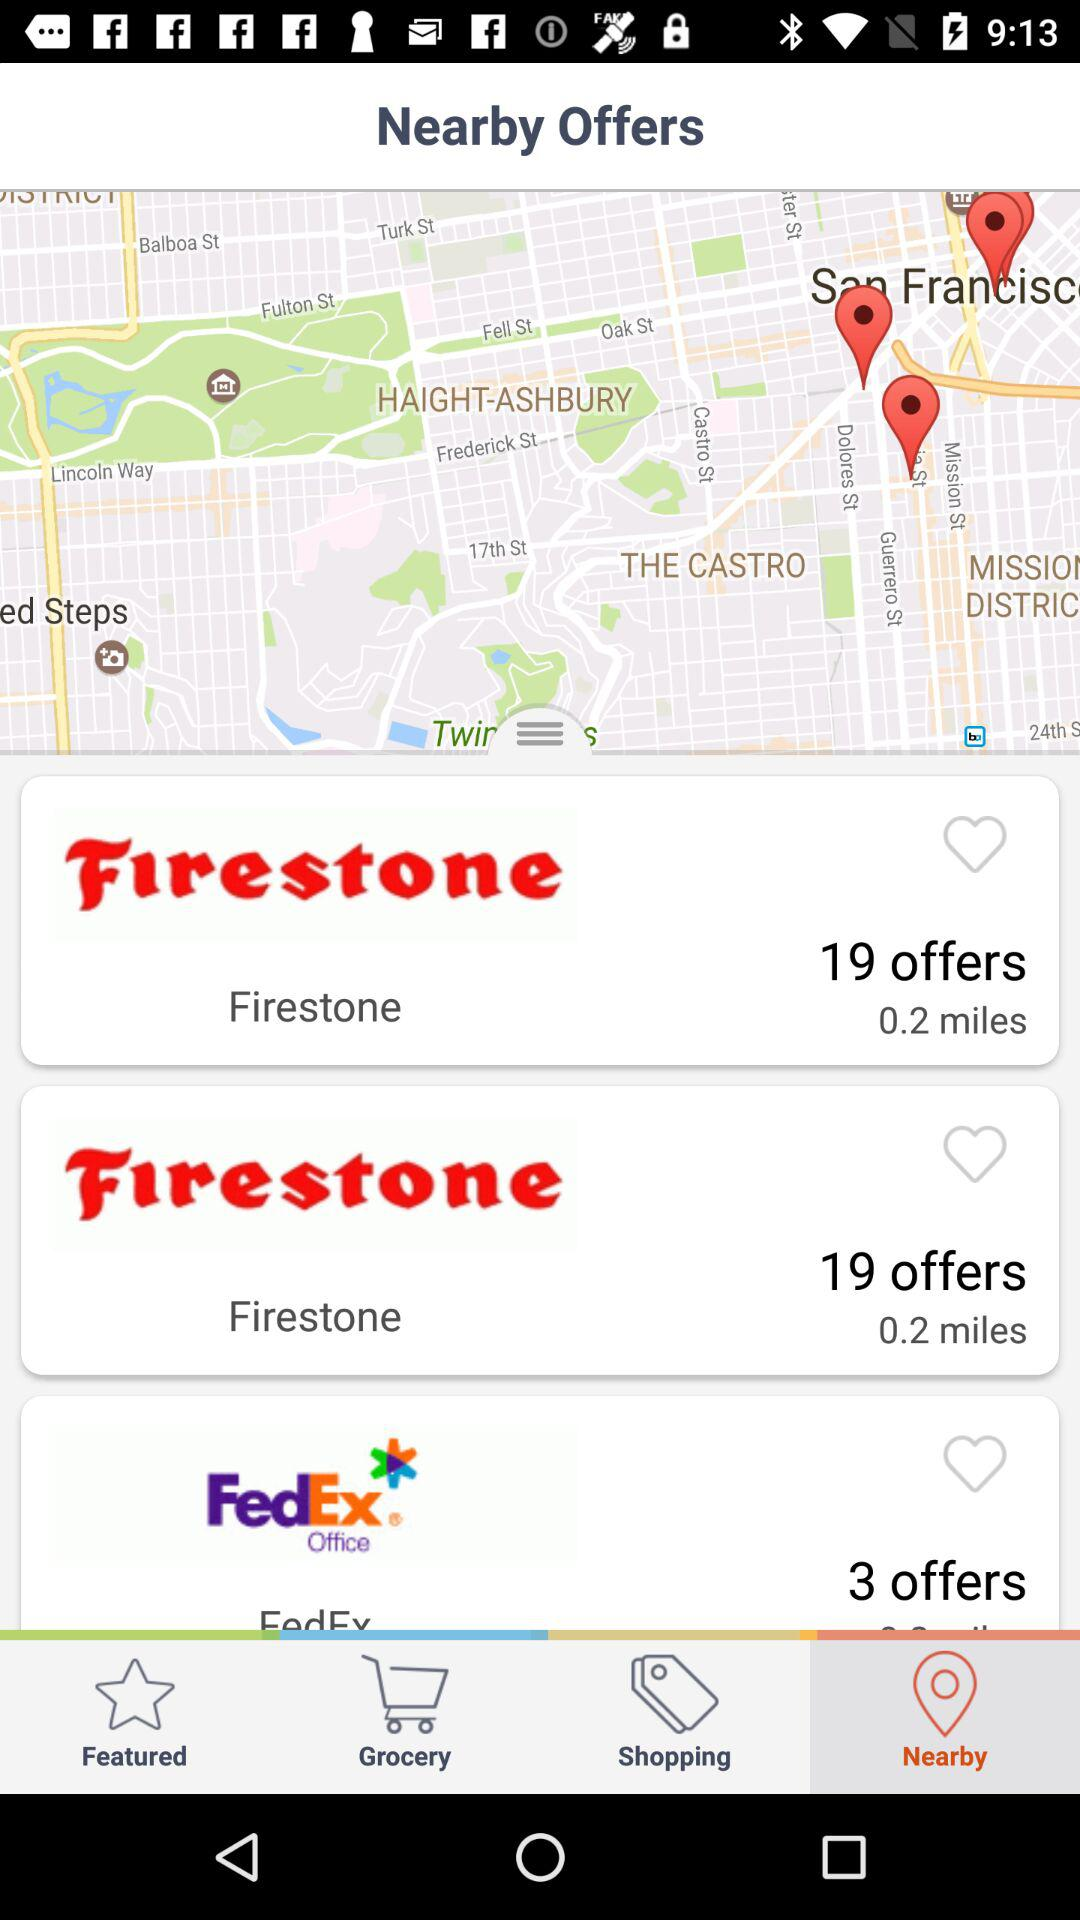How many offers are there for "FedEx"? There are 3 offers for "FedEx". 